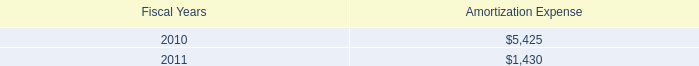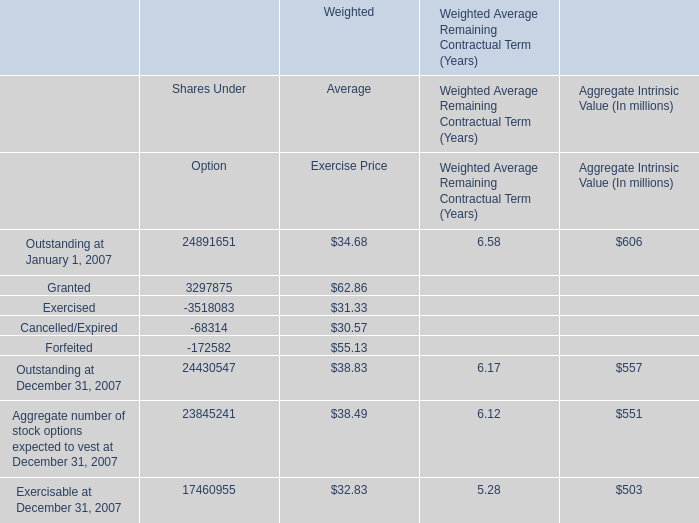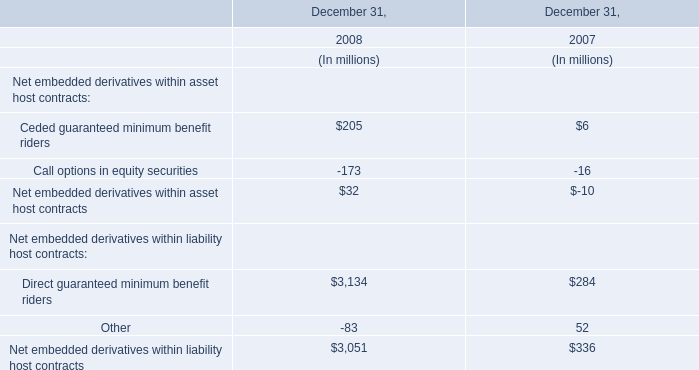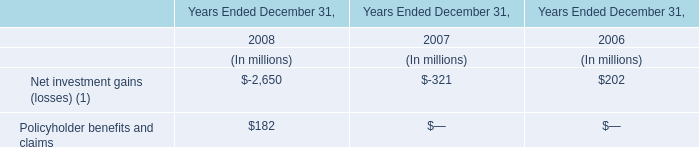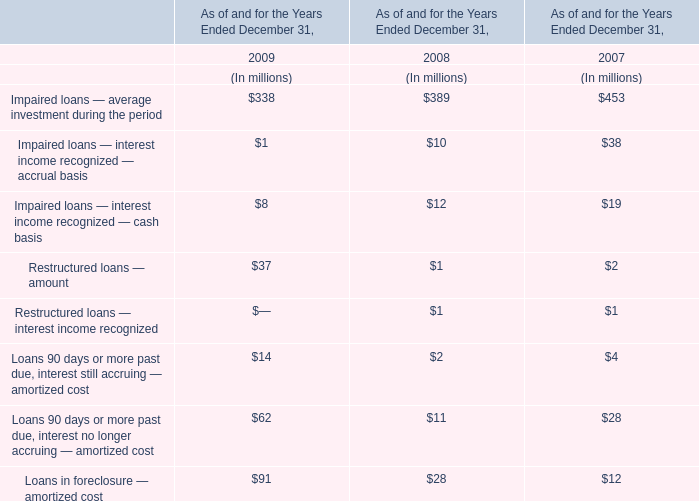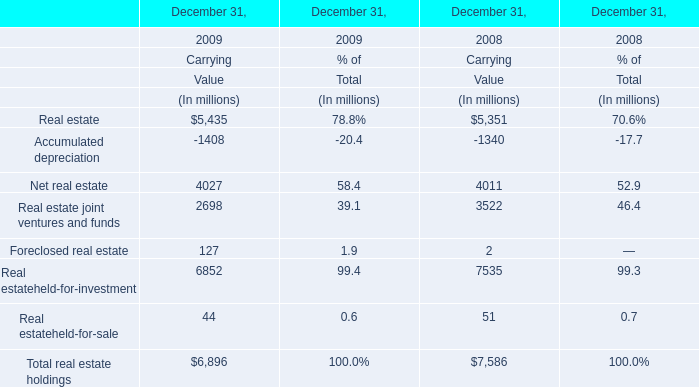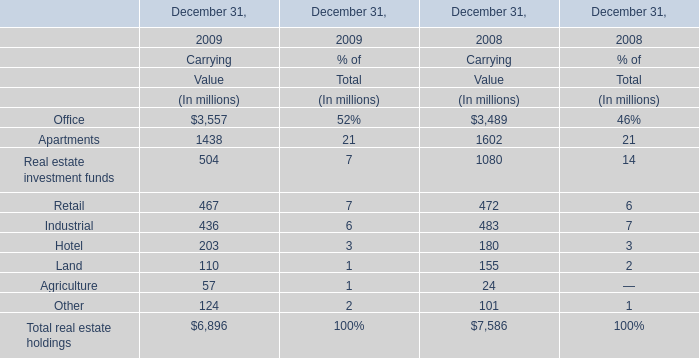Which year is Impaired loans — average investment during the period the least? 
Answer: 2009. 